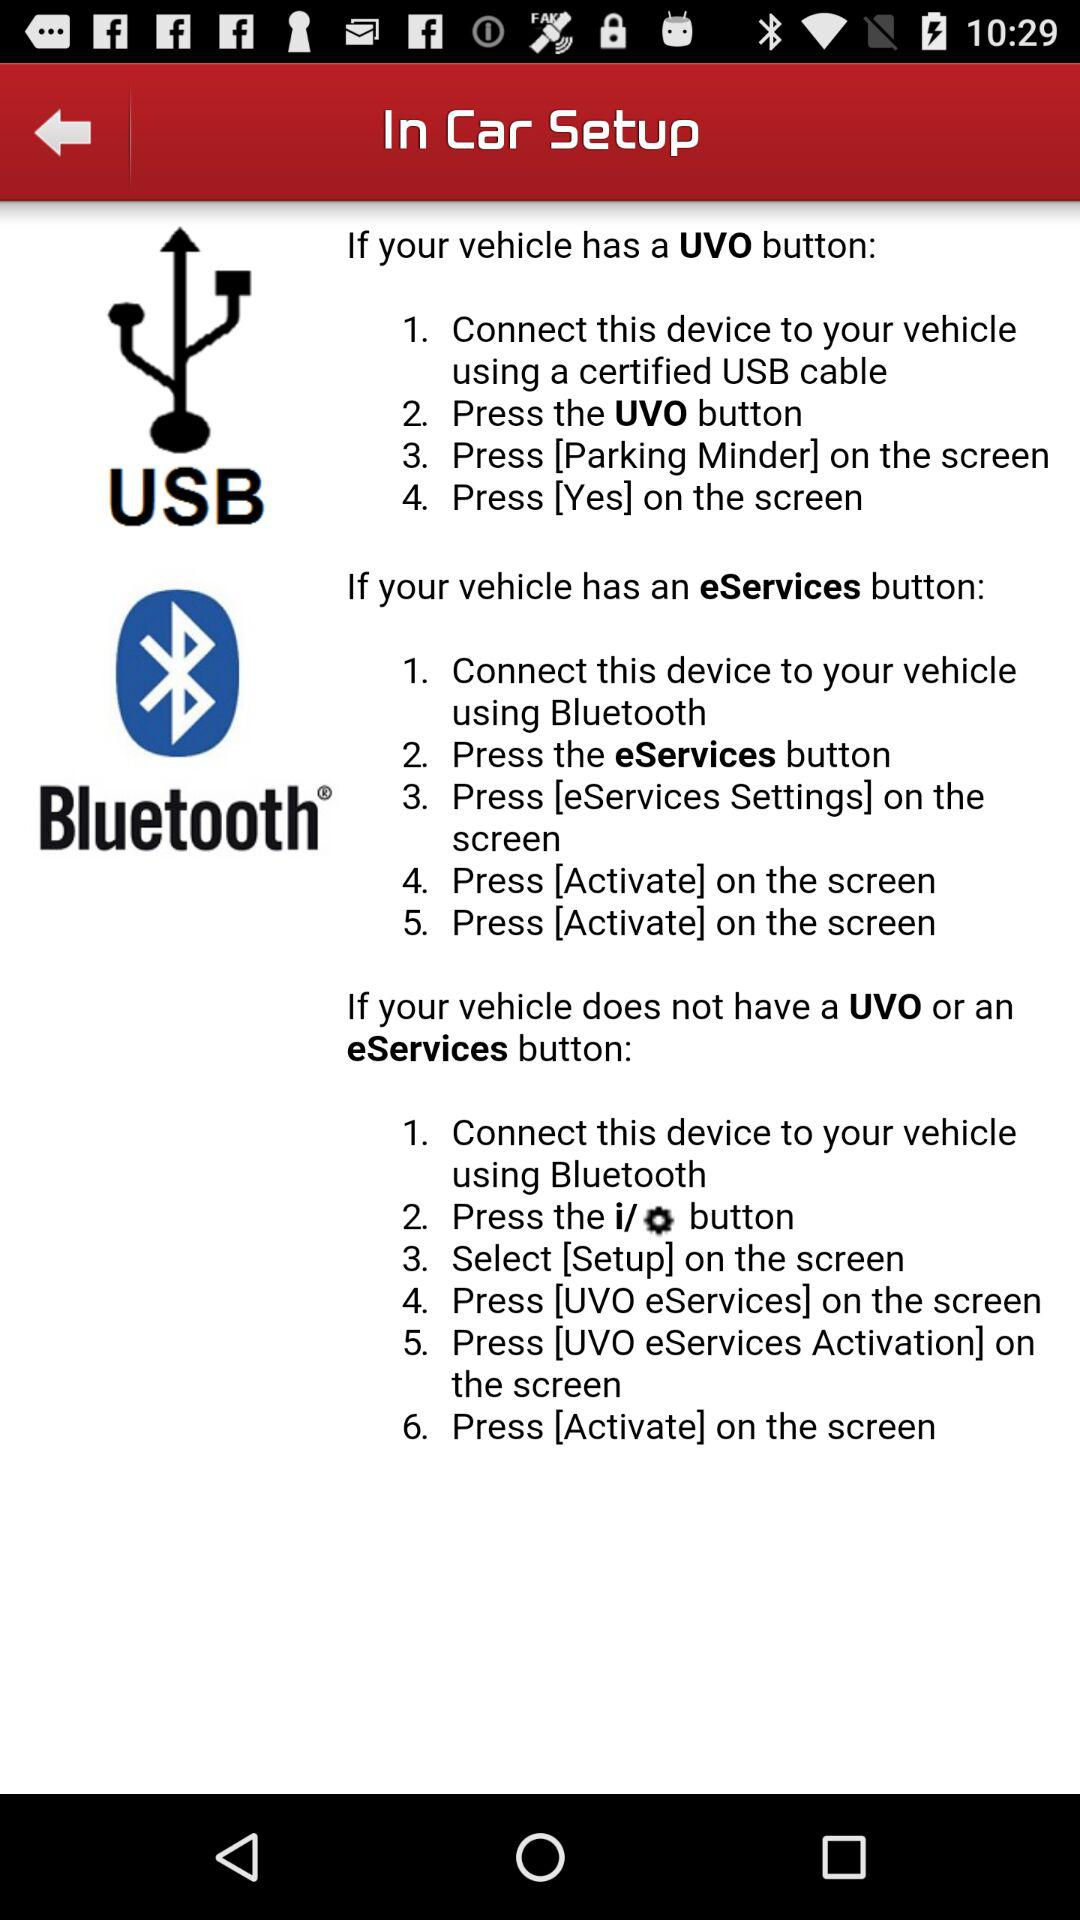How to connect if my vehicle doesn't have a UVO or an eServices button? If your vehicle doesn't have a UVO or an eServices button, you can connect by "Connect this device to your vehicle using Bluetooth", "Press the i/settings button", "Select [Setup] on the screen", "Press [UVO eServices] on the screen", "Press [UVO eServices Activation] on the screen" and "Press [Activate] on the screen". 